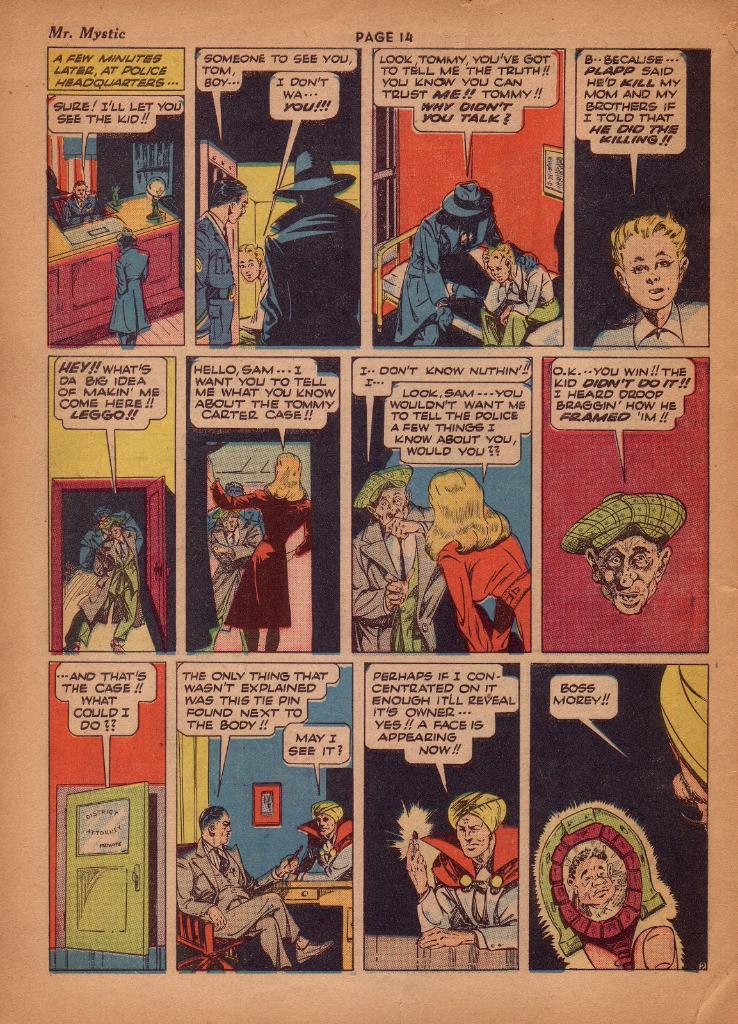What old comic book is this?
Your answer should be very brief. Mr. mystic. What does the last speech bubble on the page say?
Offer a very short reply. Boss morey. 